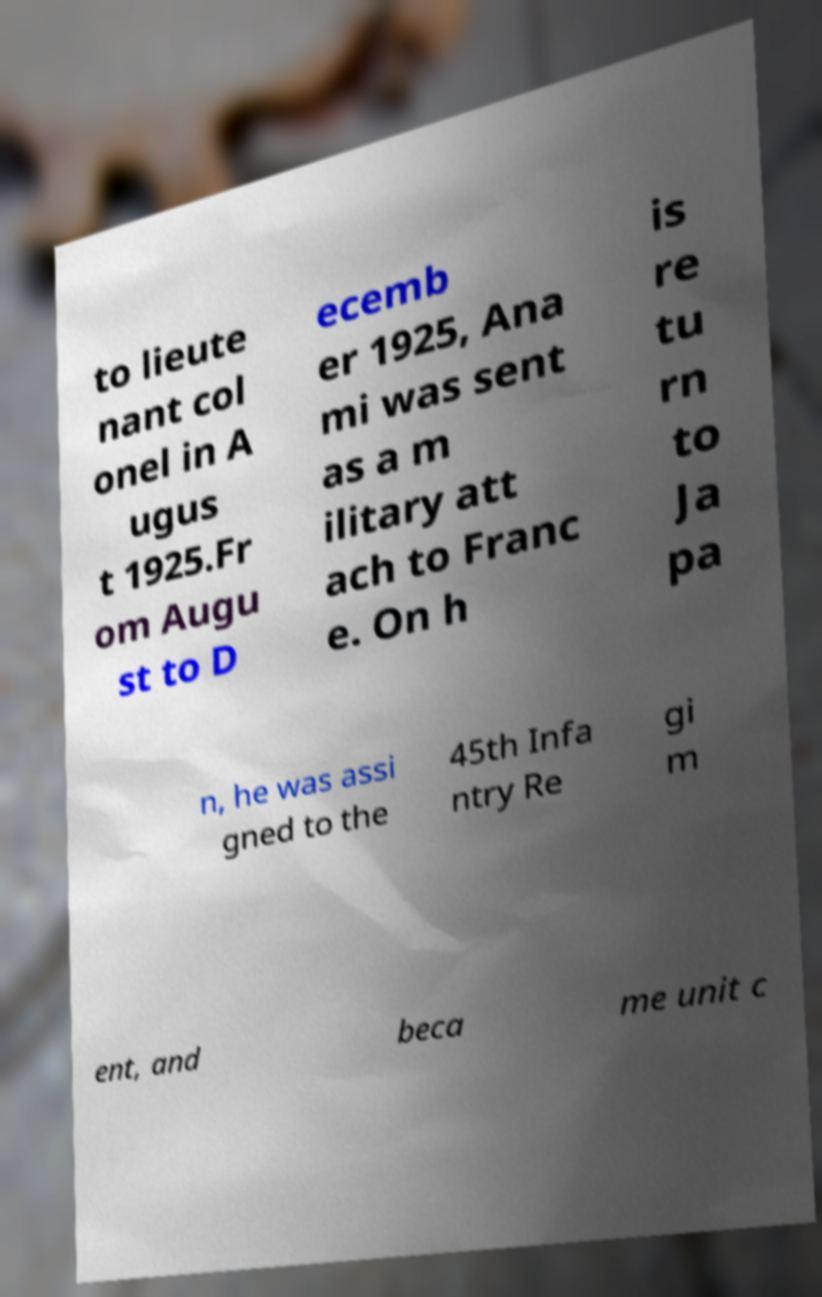I need the written content from this picture converted into text. Can you do that? to lieute nant col onel in A ugus t 1925.Fr om Augu st to D ecemb er 1925, Ana mi was sent as a m ilitary att ach to Franc e. On h is re tu rn to Ja pa n, he was assi gned to the 45th Infa ntry Re gi m ent, and beca me unit c 